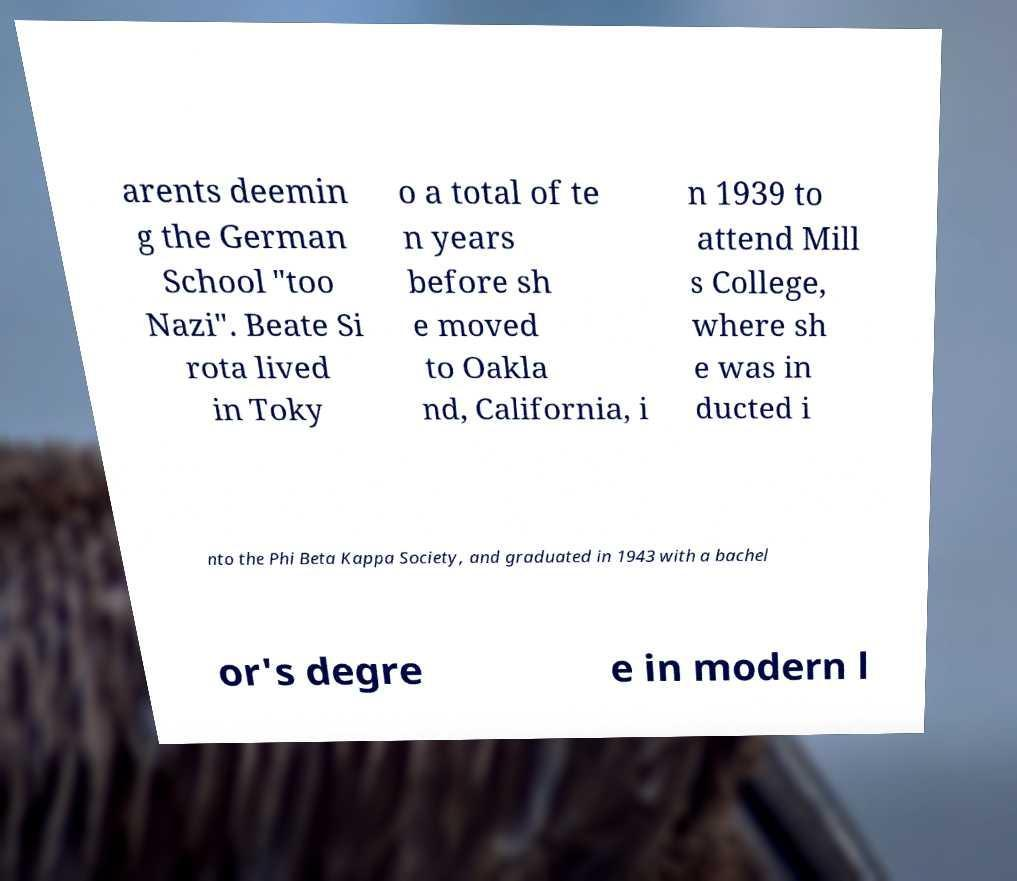What messages or text are displayed in this image? I need them in a readable, typed format. arents deemin g the German School "too Nazi". Beate Si rota lived in Toky o a total of te n years before sh e moved to Oakla nd, California, i n 1939 to attend Mill s College, where sh e was in ducted i nto the Phi Beta Kappa Society, and graduated in 1943 with a bachel or's degre e in modern l 